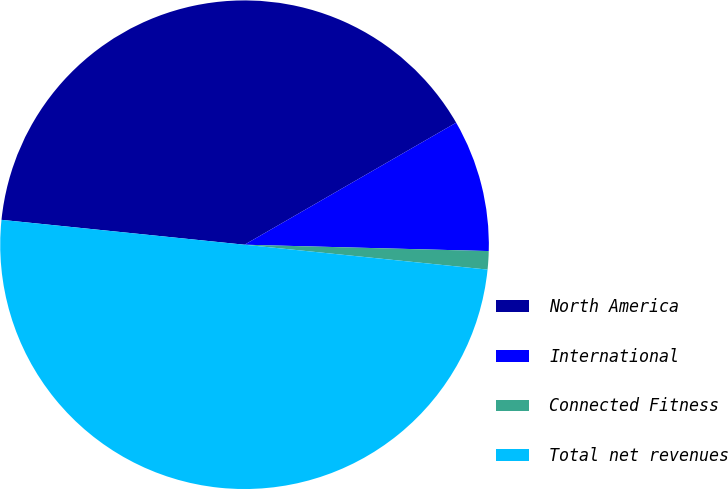Convert chart to OTSL. <chart><loc_0><loc_0><loc_500><loc_500><pie_chart><fcel>North America<fcel>International<fcel>Connected Fitness<fcel>Total net revenues<nl><fcel>40.05%<fcel>8.74%<fcel>1.21%<fcel>50.0%<nl></chart> 